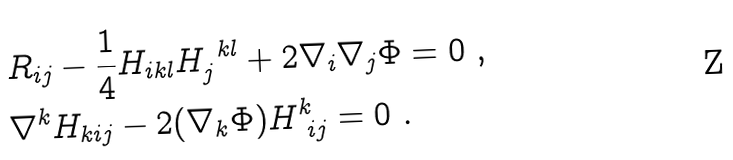Convert formula to latex. <formula><loc_0><loc_0><loc_500><loc_500>& R _ { i j } - \frac { 1 } { 4 } H _ { i k l } H _ { j } ^ { \ k l } + 2 \nabla _ { i } \nabla _ { j } \Phi = 0 \ , \\ & \nabla ^ { k } H _ { k i j } - 2 ( \nabla _ { k } \Phi ) H ^ { k } _ { \ i j } = 0 \ .</formula> 